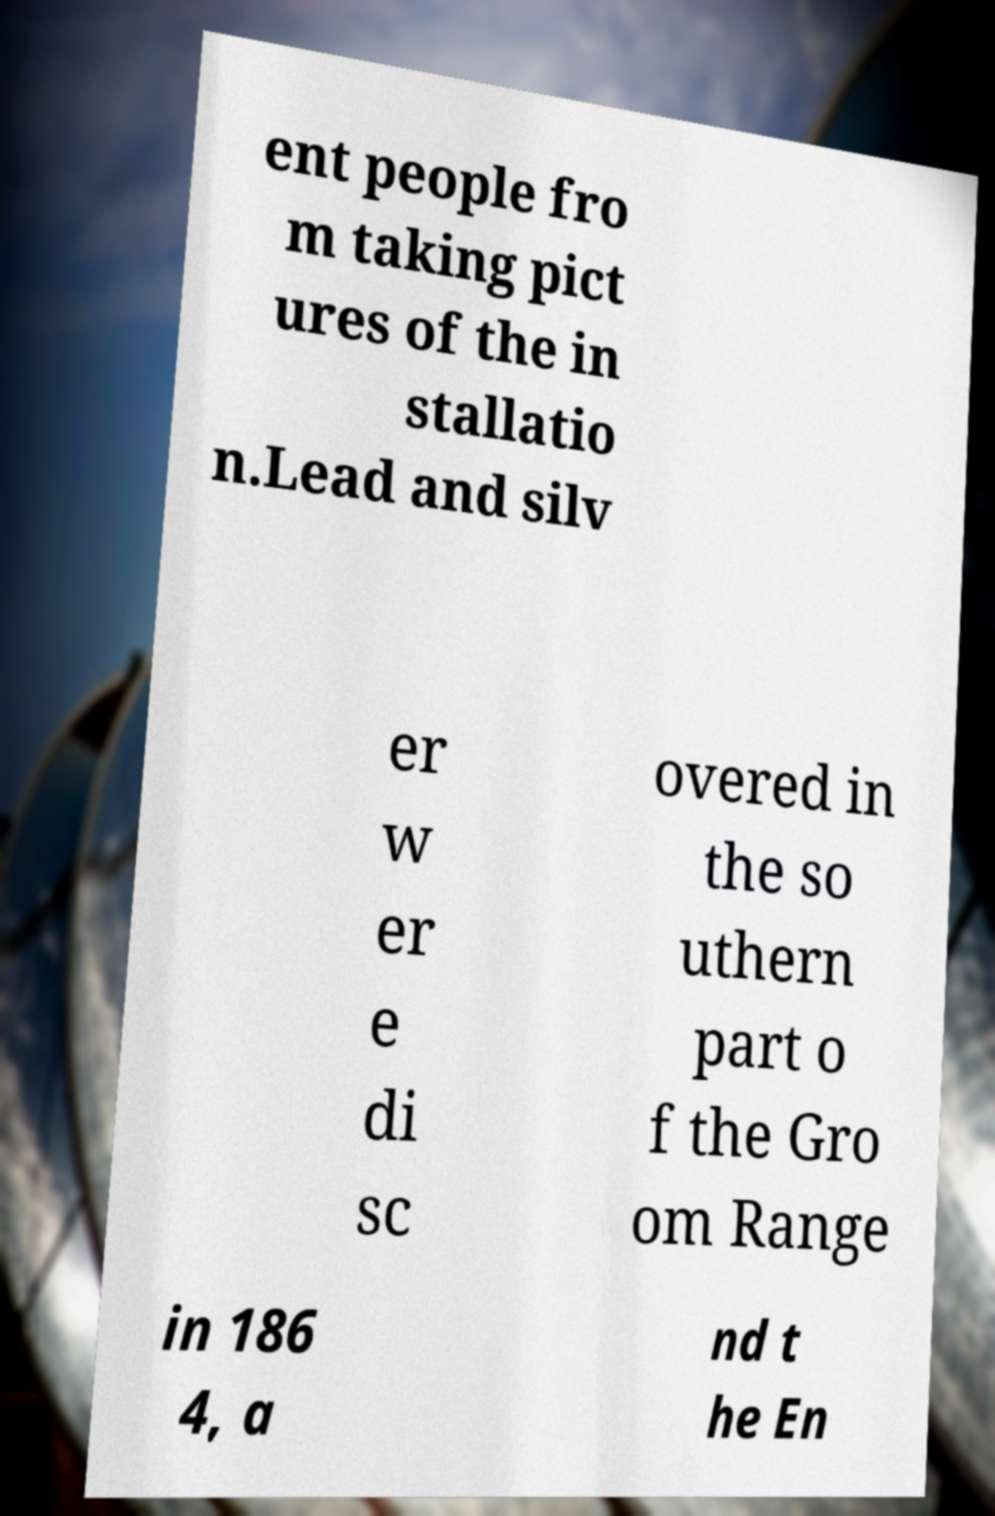Could you assist in decoding the text presented in this image and type it out clearly? ent people fro m taking pict ures of the in stallatio n.Lead and silv er w er e di sc overed in the so uthern part o f the Gro om Range in 186 4, a nd t he En 